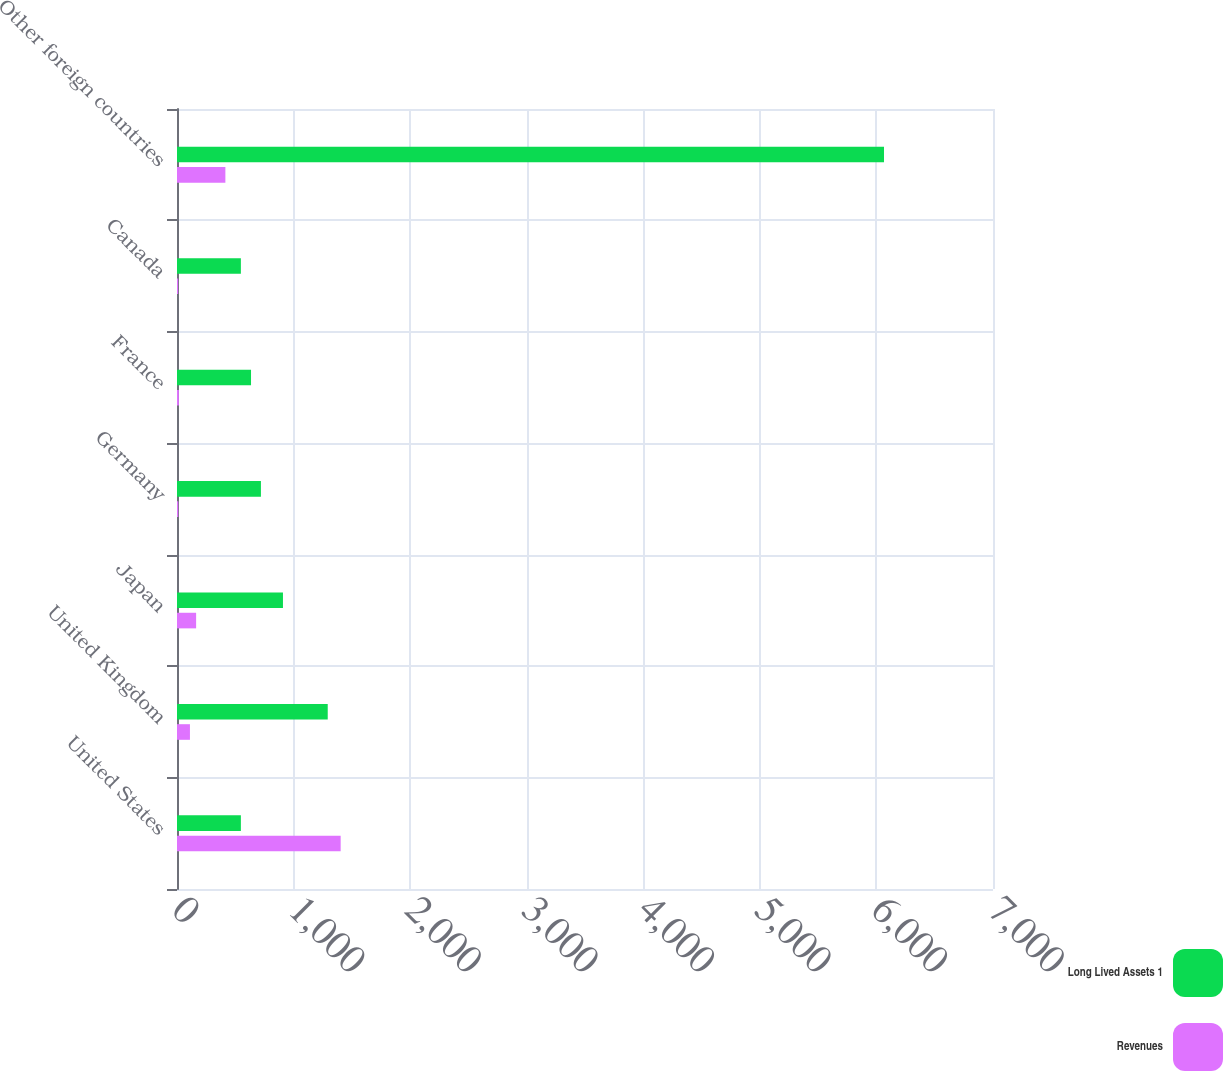Convert chart. <chart><loc_0><loc_0><loc_500><loc_500><stacked_bar_chart><ecel><fcel>United States<fcel>United Kingdom<fcel>Japan<fcel>Germany<fcel>France<fcel>Canada<fcel>Other foreign countries<nl><fcel>Long Lived Assets 1<fcel>548<fcel>1293<fcel>909<fcel>720<fcel>635<fcel>548<fcel>6065<nl><fcel>Revenues<fcel>1404<fcel>111<fcel>164<fcel>11<fcel>16<fcel>10<fcel>415<nl></chart> 